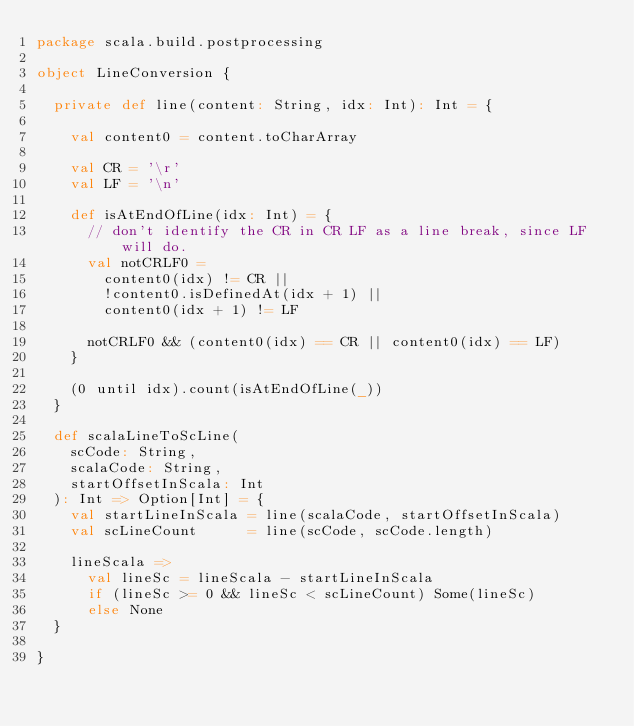<code> <loc_0><loc_0><loc_500><loc_500><_Scala_>package scala.build.postprocessing

object LineConversion {

  private def line(content: String, idx: Int): Int = {

    val content0 = content.toCharArray

    val CR = '\r'
    val LF = '\n'

    def isAtEndOfLine(idx: Int) = {
      // don't identify the CR in CR LF as a line break, since LF will do.
      val notCRLF0 =
        content0(idx) != CR ||
        !content0.isDefinedAt(idx + 1) ||
        content0(idx + 1) != LF

      notCRLF0 && (content0(idx) == CR || content0(idx) == LF)
    }

    (0 until idx).count(isAtEndOfLine(_))
  }

  def scalaLineToScLine(
    scCode: String,
    scalaCode: String,
    startOffsetInScala: Int
  ): Int => Option[Int] = {
    val startLineInScala = line(scalaCode, startOffsetInScala)
    val scLineCount      = line(scCode, scCode.length)

    lineScala =>
      val lineSc = lineScala - startLineInScala
      if (lineSc >= 0 && lineSc < scLineCount) Some(lineSc)
      else None
  }

}
</code> 